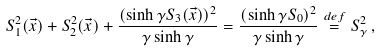Convert formula to latex. <formula><loc_0><loc_0><loc_500><loc_500>S _ { 1 } ^ { 2 } ( \vec { x } ) + S _ { 2 } ^ { 2 } ( \vec { x } ) + \frac { ( \sinh \gamma S _ { 3 } ( \vec { x } ) ) ^ { 2 } } { \gamma \sinh \gamma } = \frac { ( \sinh \gamma S _ { 0 } ) ^ { 2 } } { \gamma \sinh \gamma } \stackrel { d e f } { = } S _ { \gamma } ^ { 2 } \, ,</formula> 